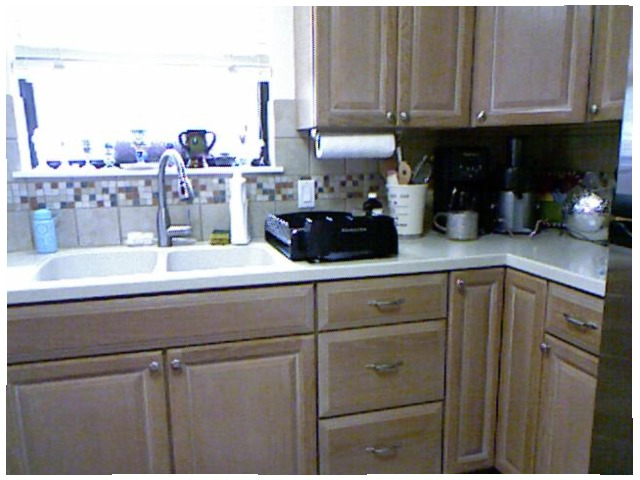<image>
Is the sink behind the drawer? No. The sink is not behind the drawer. From this viewpoint, the sink appears to be positioned elsewhere in the scene. 